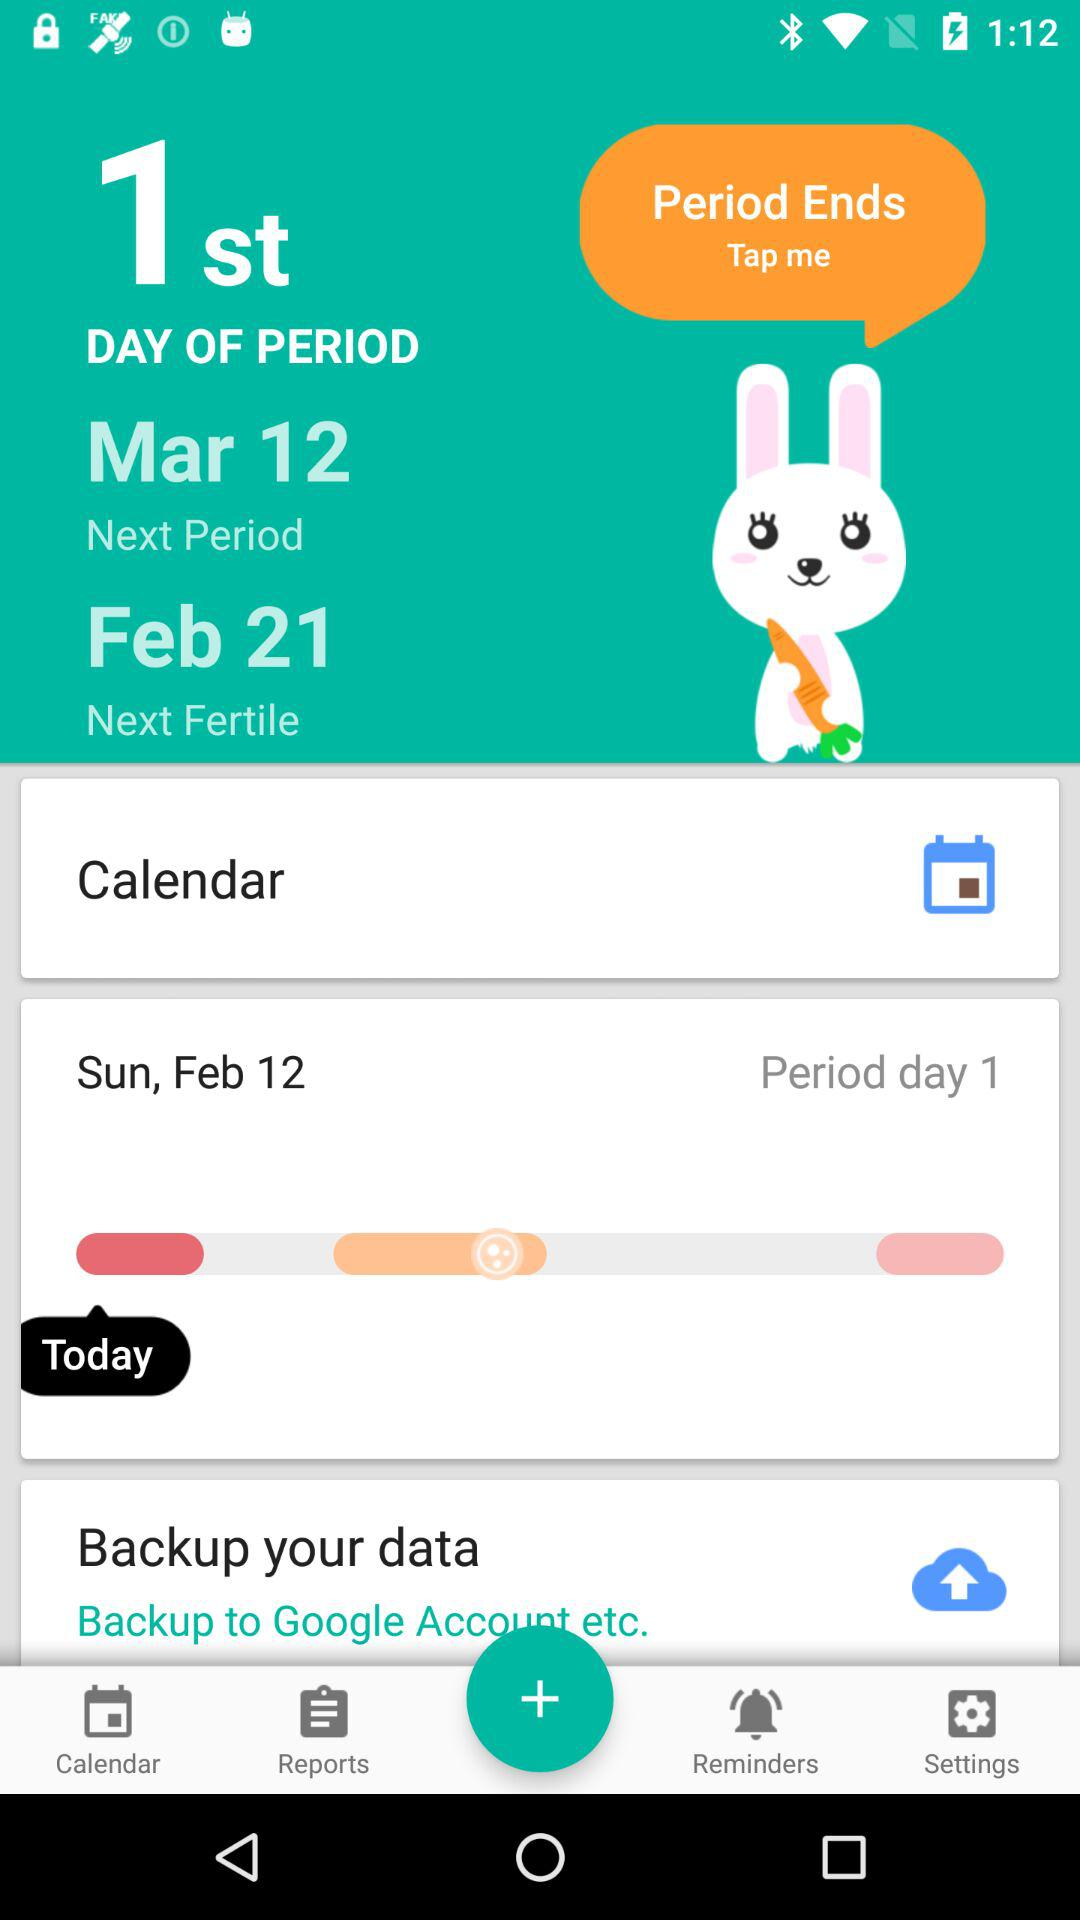What is the next fertile date? The next fertile date is February 21. 